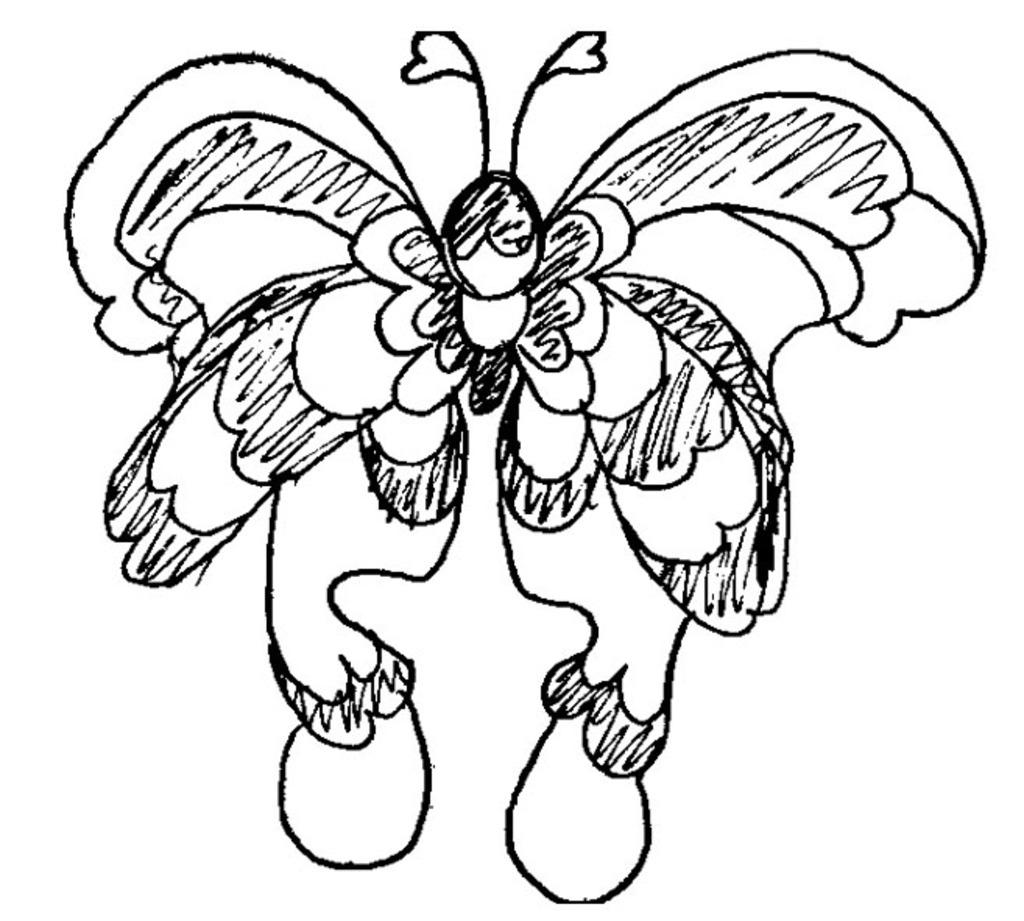What is depicted in the image? There is a drawing of a butterfly in the image. What color is the background of the image? The background of the image is white. Reasoning: Let' Let's think step by step in order to produce the conversation. We start by identifying the main subject of the image, which is the drawing of a butterfly. Then, we describe the background color, which is white. We avoid asking questions that cannot be answered definitively with the information given and ensure that the language is simple and clear. Absurd Question/Answer: What type of disease is affecting the butterfly in the image? There is no indication of any disease affecting the butterfly in the image; it is a drawing of a butterfly on a white background. 